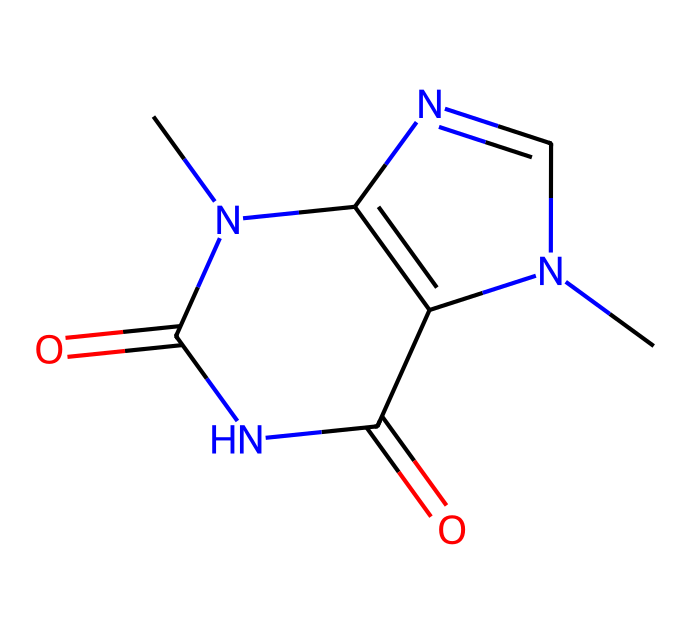What is the molecular formula of theobromine? By analyzing the SMILES representation (CN1C=NC2=C1C(=O)NC(=O)N2C), we can identify the atoms present. Counting carbon (C), nitrogen (N), and oxygen (O) gives us a molecular formula of C7H8N4O2.
Answer: C7H8N4O2 How many rings are present in the theobromine structure? The structure can be visualized from the SMILES drawing, showing two interconnected rings, indicating that there are two ring structures in total.
Answer: 2 What type of chemical is theobromine classified as? The presence of nitrogen atoms and the specific arrangement of the structure identifies this compound as an alkaloid, which is a class of naturally occurring organic compounds containing basic nitrogen atoms.
Answer: alkaloid What is the total number of oxygen atoms in theobromine? By inspecting the chemical structure derived from the SMILES, two oxygen atoms can be identified in the molecule, specifically connected to carbon atoms in the structure.
Answer: 2 Can theobromine act as a stimulant? Theobromine’s structural features share similarities with caffeine, which is known for its stimulant effects; thus, the presence of nitrogen and its specific interaction with the central nervous system suggest that it can act as a stimulant.
Answer: yes What functional groups are present in theobromine? Examining the structure reveals the presence of two carbonyl groups (C=O), which are characteristic of amides, and other nitrogen functionalities, defining its unique properties and behavior as a chemical.
Answer: amides 